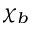<formula> <loc_0><loc_0><loc_500><loc_500>\chi _ { b }</formula> 